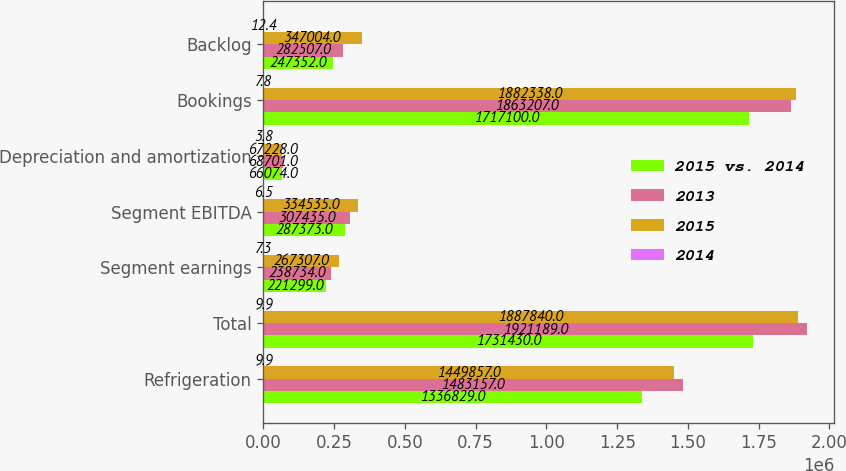<chart> <loc_0><loc_0><loc_500><loc_500><stacked_bar_chart><ecel><fcel>Refrigeration<fcel>Total<fcel>Segment earnings<fcel>Segment EBITDA<fcel>Depreciation and amortization<fcel>Bookings<fcel>Backlog<nl><fcel>2015 vs. 2014<fcel>1.33683e+06<fcel>1.73143e+06<fcel>221299<fcel>287373<fcel>66074<fcel>1.7171e+06<fcel>247352<nl><fcel>2013<fcel>1.48316e+06<fcel>1.92119e+06<fcel>238734<fcel>307435<fcel>68701<fcel>1.86321e+06<fcel>282507<nl><fcel>2015<fcel>1.44986e+06<fcel>1.88784e+06<fcel>267307<fcel>334535<fcel>67228<fcel>1.88234e+06<fcel>347004<nl><fcel>2014<fcel>9.9<fcel>9.9<fcel>7.3<fcel>6.5<fcel>3.8<fcel>7.8<fcel>12.4<nl></chart> 